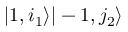Convert formula to latex. <formula><loc_0><loc_0><loc_500><loc_500>| 1 , i _ { 1 } \rangle | - 1 , j _ { 2 } \rangle</formula> 